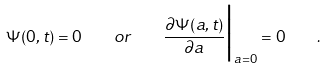Convert formula to latex. <formula><loc_0><loc_0><loc_500><loc_500>\Psi ( 0 , t ) = 0 \quad o r \quad \frac { \partial \Psi ( a , t ) } { \partial a } \Big | _ { a = 0 } = 0 \quad .</formula> 